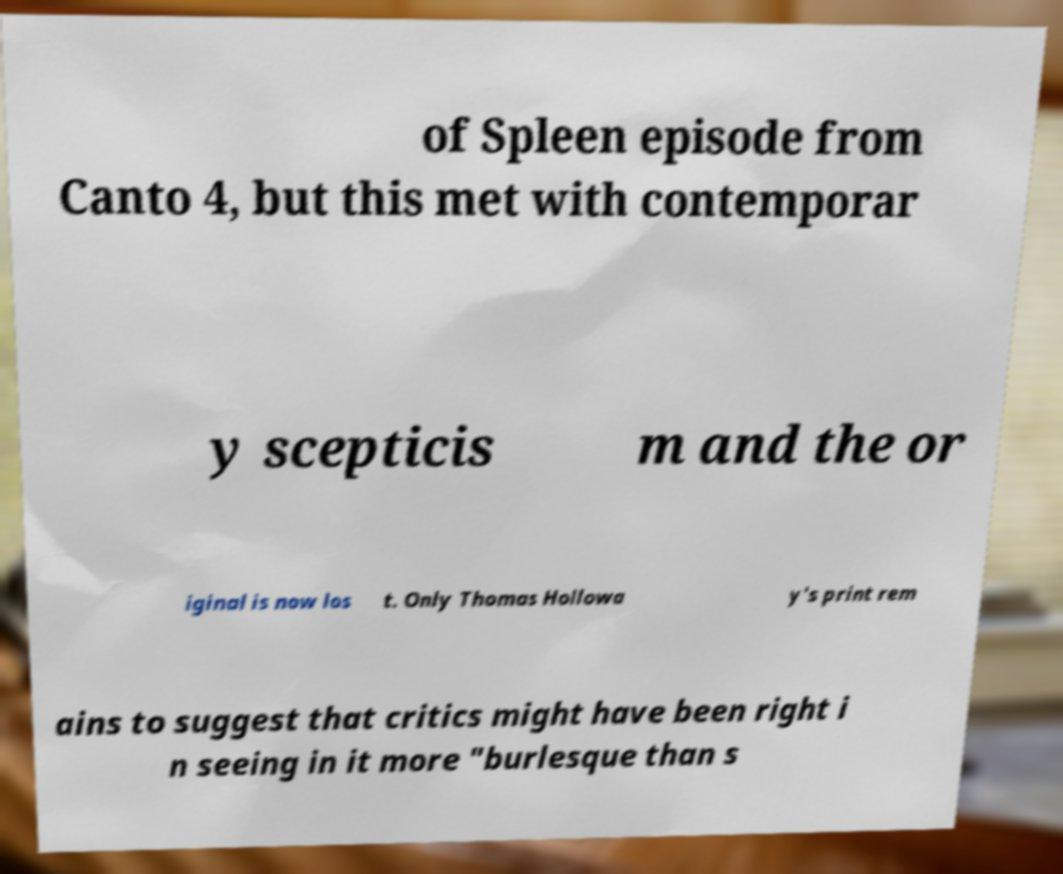Could you extract and type out the text from this image? of Spleen episode from Canto 4, but this met with contemporar y scepticis m and the or iginal is now los t. Only Thomas Hollowa y's print rem ains to suggest that critics might have been right i n seeing in it more "burlesque than s 